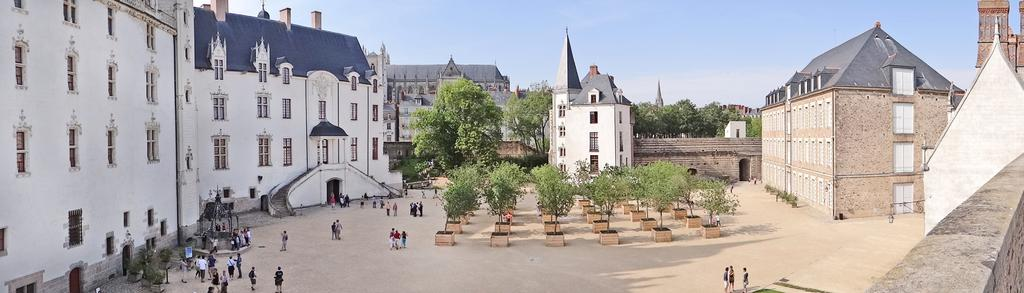What type of structures can be seen in the image? There are buildings in the image. What natural elements are present in the image? There are trees and plants in the image. What is a specific feature in the image related to water? There is a well in the image. What type of signage or markers are visible in the image? There are boards in the image. Are there any living beings present in the image? Yes, there are people in the image. What type of illumination is present in the image? There are lights in the image. What part of the natural environment can be seen in the image? The sky is visible in the image. What architectural feature is present in the image? There are steps in the image. What general category of objects can be seen in the image? There are objects in the image. Who is the manager of the grass in the image? There is no grass present in the image, and therefore no manager for it. What type of mother can be seen in the image? There is no mother present in the image. 